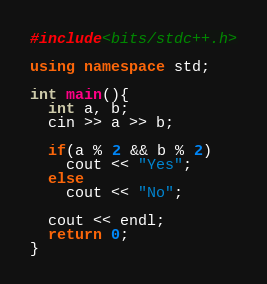Convert code to text. <code><loc_0><loc_0><loc_500><loc_500><_C++_>#include<bits/stdc++.h>

using namespace std;

int main(){
  int a, b;
  cin >> a >> b;
  
  if(a % 2 && b % 2)
    cout << "Yes";
  else
    cout << "No";
  
  cout << endl;
  return 0;
}</code> 